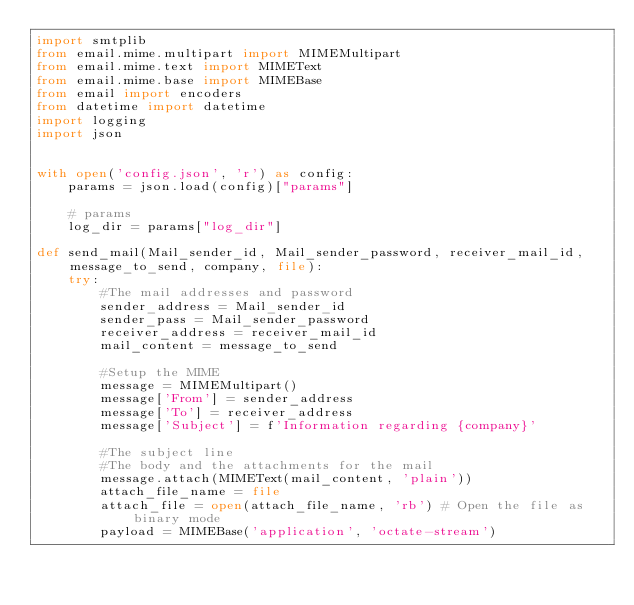<code> <loc_0><loc_0><loc_500><loc_500><_Python_>import smtplib
from email.mime.multipart import MIMEMultipart
from email.mime.text import MIMEText
from email.mime.base import MIMEBase
from email import encoders
from datetime import datetime
import logging
import json  


with open('config.json', 'r') as config:
    params = json.load(config)["params"]
    
    # params
    log_dir = params["log_dir"]

def send_mail(Mail_sender_id, Mail_sender_password, receiver_mail_id, message_to_send, company, file):
    try:
        #The mail addresses and password
        sender_address = Mail_sender_id
        sender_pass = Mail_sender_password
        receiver_address = receiver_mail_id
        mail_content = message_to_send

        #Setup the MIME
        message = MIMEMultipart()
        message['From'] = sender_address
        message['To'] = receiver_address
        message['Subject'] = f'Information regarding {company}'

        #The subject line
        #The body and the attachments for the mail
        message.attach(MIMEText(mail_content, 'plain'))
        attach_file_name = file
        attach_file = open(attach_file_name, 'rb') # Open the file as binary mode
        payload = MIMEBase('application', 'octate-stream')</code> 